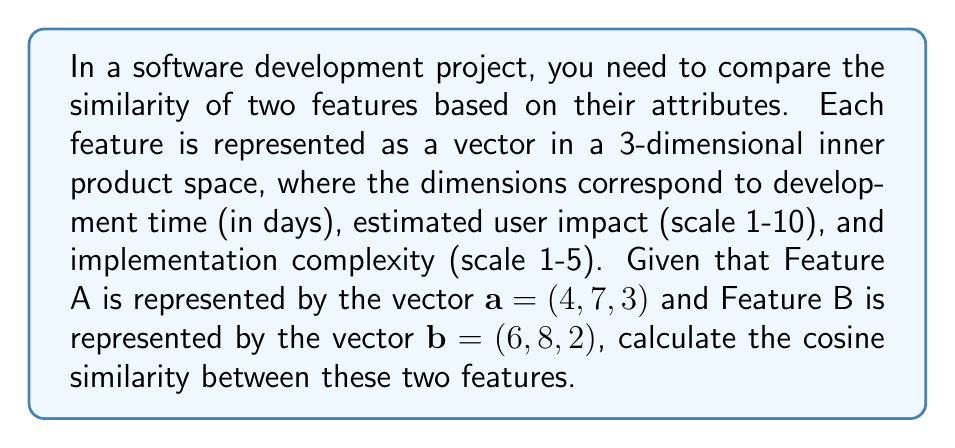Help me with this question. To solve this problem, we'll use the concept of cosine similarity in inner product spaces. Cosine similarity measures the cosine of the angle between two vectors and is calculated using the inner product of the vectors and their magnitudes.

The formula for cosine similarity is:

$$\text{cosine similarity} = \frac{\langle a, b \rangle}{\|a\| \|b\|}$$

Where $\langle a, b \rangle$ is the inner product of vectors $a$ and $b$, and $\|a\|$ and $\|b\|$ are the magnitudes (lengths) of vectors $a$ and $b$ respectively.

Step 1: Calculate the inner product $\langle a, b \rangle$
$$\langle a, b \rangle = 4 \cdot 6 + 7 \cdot 8 + 3 \cdot 2 = 24 + 56 + 6 = 86$$

Step 2: Calculate the magnitude of vector $a$
$$\|a\| = \sqrt{4^2 + 7^2 + 3^2} = \sqrt{16 + 49 + 9} = \sqrt{74}$$

Step 3: Calculate the magnitude of vector $b$
$$\|b\| = \sqrt{6^2 + 8^2 + 2^2} = \sqrt{36 + 64 + 4} = \sqrt{104}$$

Step 4: Apply the cosine similarity formula
$$\text{cosine similarity} = \frac{86}{\sqrt{74} \cdot \sqrt{104}} = \frac{86}{\sqrt{7696}} \approx 0.9808$$
Answer: The cosine similarity between Feature A and Feature B is approximately 0.9808. 